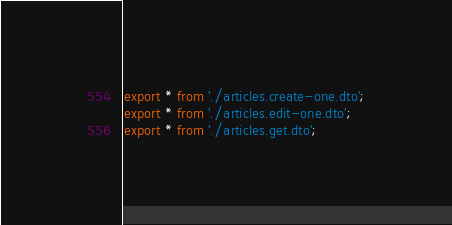Convert code to text. <code><loc_0><loc_0><loc_500><loc_500><_TypeScript_>export * from './articles.create-one.dto';
export * from './articles.edit-one.dto';
export * from './articles.get.dto';
</code> 